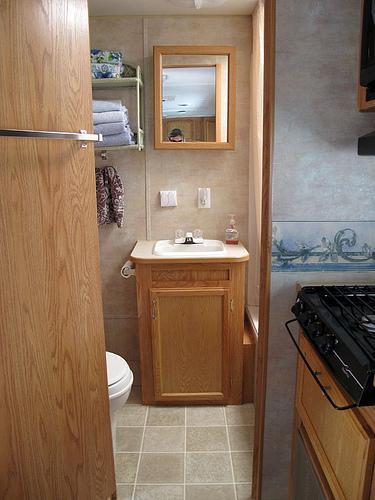How many mirrors are pictured?
Give a very brief answer. 1. How many shelves are there top left?
Give a very brief answer. 2. How many white coloured towels are there on the rack on top of wall?
Give a very brief answer. 4. 